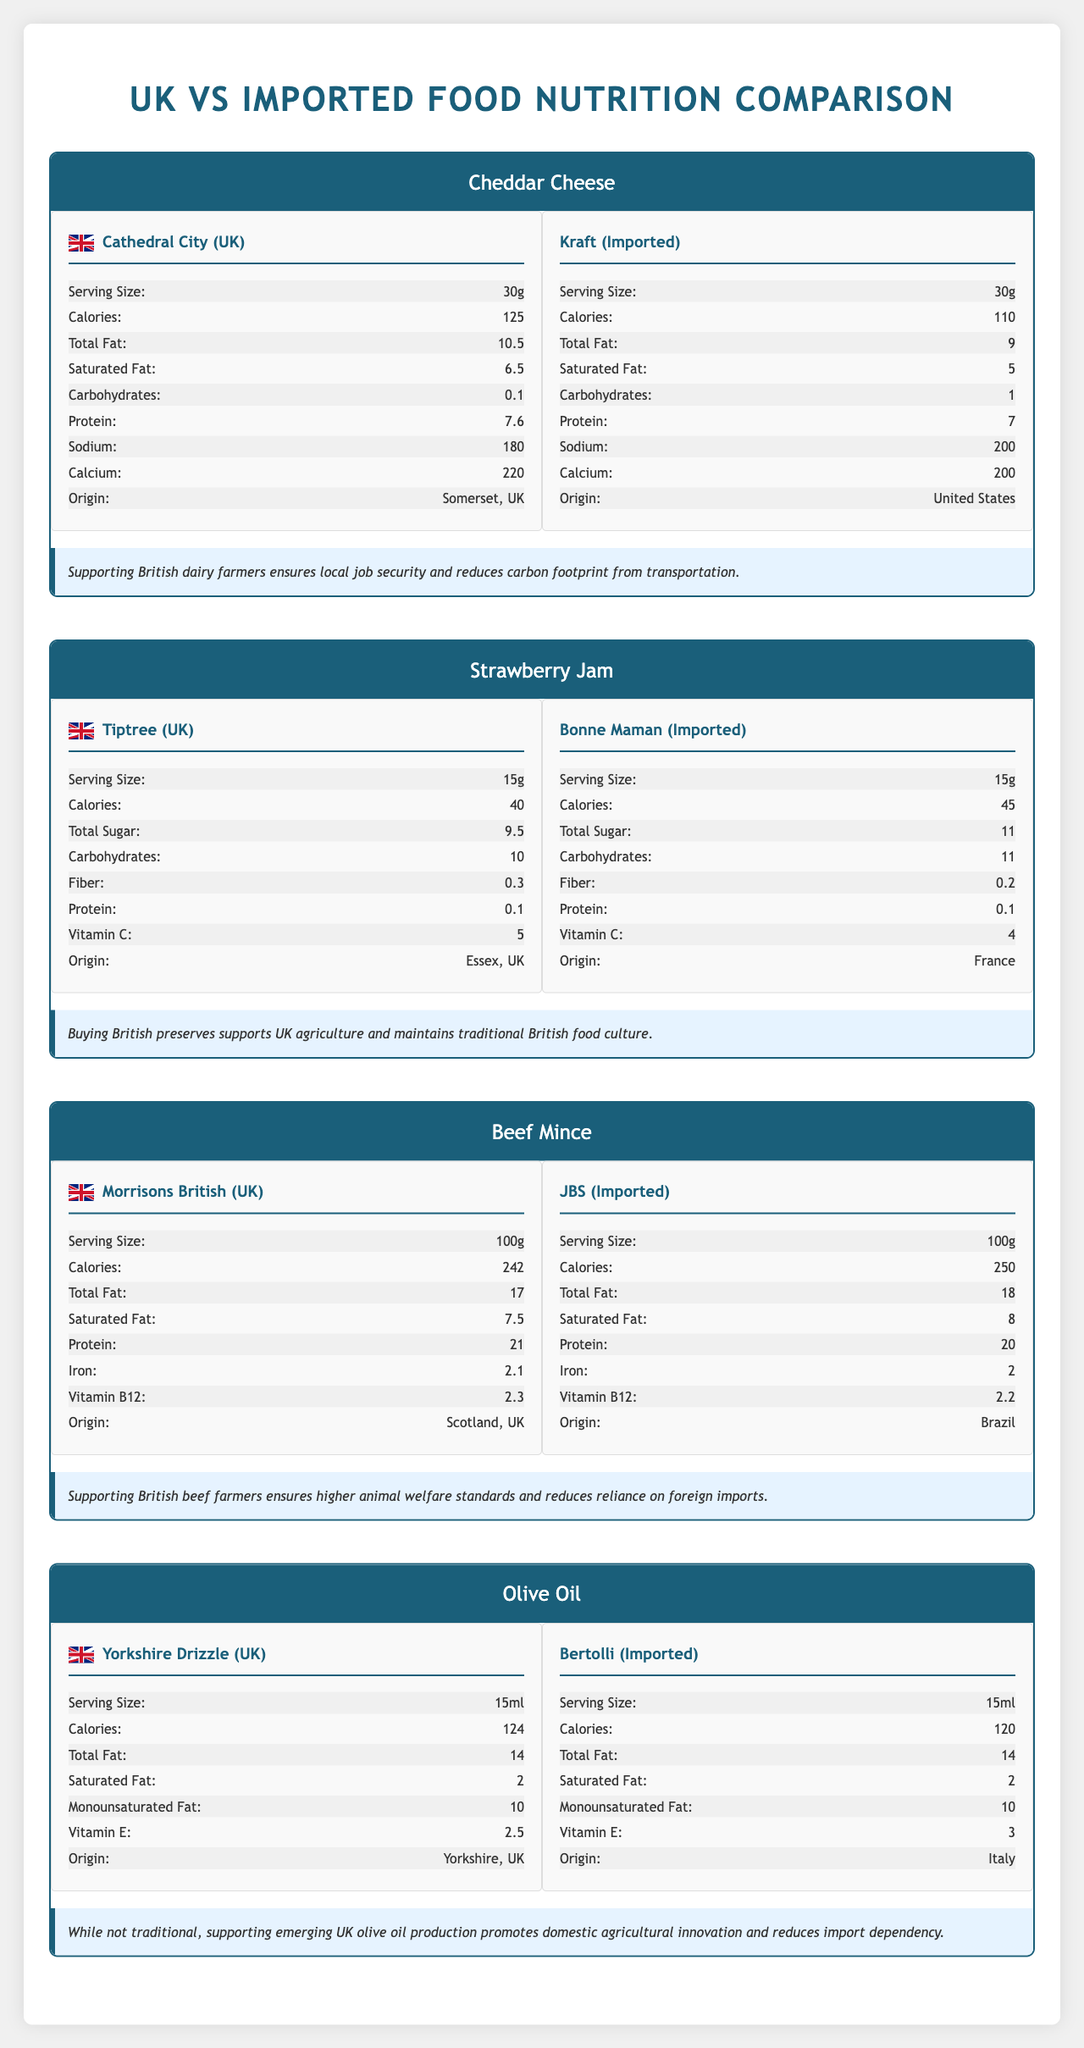what is the serving size of the Cathedral City Cheddar Cheese? According to the nutrition facts for Cathedral City Cheddar Cheese, the serving size is listed as 30g.
Answer: 30g what is the calorie difference between the UK-produced Cheddar Cheese and the imported one? The UK-produced Cheddar Cheese has 125 calories, while the imported Cheddar Cheese has 110 calories, making a difference of 15 calories.
Answer: 15 calories Which product has a higher total fat content in the UK's Cheddar Cheese versus the imported one? The Cathedral City Cheddar Cheese has 10.5g of total fat, while the imported Kraft Cheddar Cheese has 9g of total fat.
Answer: Cheddar Cheese (UK) What is the sodium content difference between the UK-produced Cheddar Cheese and the imported alternative? The UK-produced Cheddar Cheese has 180 mg of sodium, while the imported one has 200 mg, resulting in a difference of 20 mg.
Answer: 20 mg How much vitamin B12 is in 100g of UK-produced Beef Mince? The UK-produced Beef Mince from Morrisons contains 2.3 µg of vitamin B12 per 100g serving.
Answer: 2.3 µg which of the following has the highest total sugar content per serving?
1. Tiptree Strawberry Jam
2. Bonne Maman Strawberry Jam
3. Kraft Cheddar Cheese The Bonne Maman Strawberry Jam has 11g of total sugar per serving, Tiptree has 9.5g, and the Kraft Cheddar Cheese has 0g.
Answer: 2. Bonne Maman Strawberry Jam Which product is imported from Brazil? A. Cheddar Cheese B. Olive Oil C. Beef Mince The Beef Mince under the brand JBS is imported from Brazil.
Answer: C. Beef Mince Which of the Olive Oils provides more vitamin E? A. Yorkshire Drizzle B. Bertolli The Bertolli Olive Oil provides 3 mg of vitamin E while the Yorkshire Drizzle Olive Oil provides 2.5 mg.
Answer: B. Bertolli Does the UK-produced Olive Oil have fewer calories than the imported one? Both the UK-produced Yorkshire Drizzle and the imported Bertolli Olive Oil have 124 and 120 calories per serving respectively, making the UK-produced slightly higher in calories.
Answer: No Summarize the main idea of the document. The document presents detailed comparisons on nutritional aspects like calories, fats, sugars, proteins, sodium, vitamins, and other nutrients for each product pair and emphasizes the advantages of buying locally produced foods from a conservative viewpoint.
Answer: The document compares the nutrition facts of four pairs of food products: Cheddar Cheese, Strawberry Jam, Beef Mince, and Olive Oil, produced in the UK and imported alternatives. It highlights the nutritional differences and provides a conservative perspective on supporting local food production for economic, cultural, and environmental benefits. Which brand of Strawberry Jam contains iron? The document does not provide information about the iron content in either Tiptree or Bonne Maman Strawberry Jam.
Answer: Not enough information 